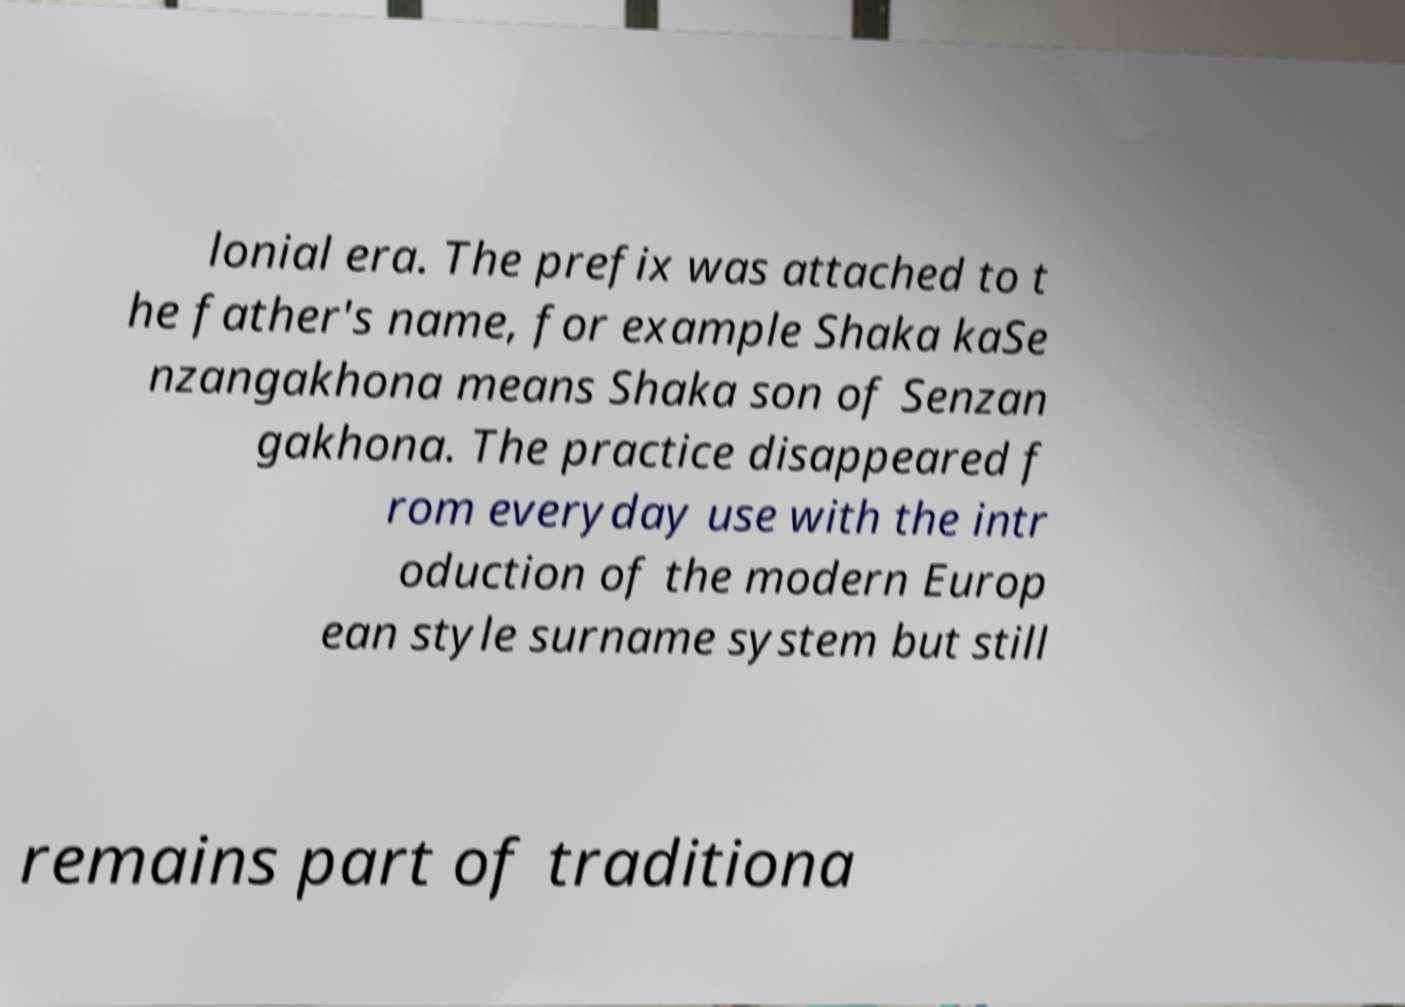Can you accurately transcribe the text from the provided image for me? lonial era. The prefix was attached to t he father's name, for example Shaka kaSe nzangakhona means Shaka son of Senzan gakhona. The practice disappeared f rom everyday use with the intr oduction of the modern Europ ean style surname system but still remains part of traditiona 